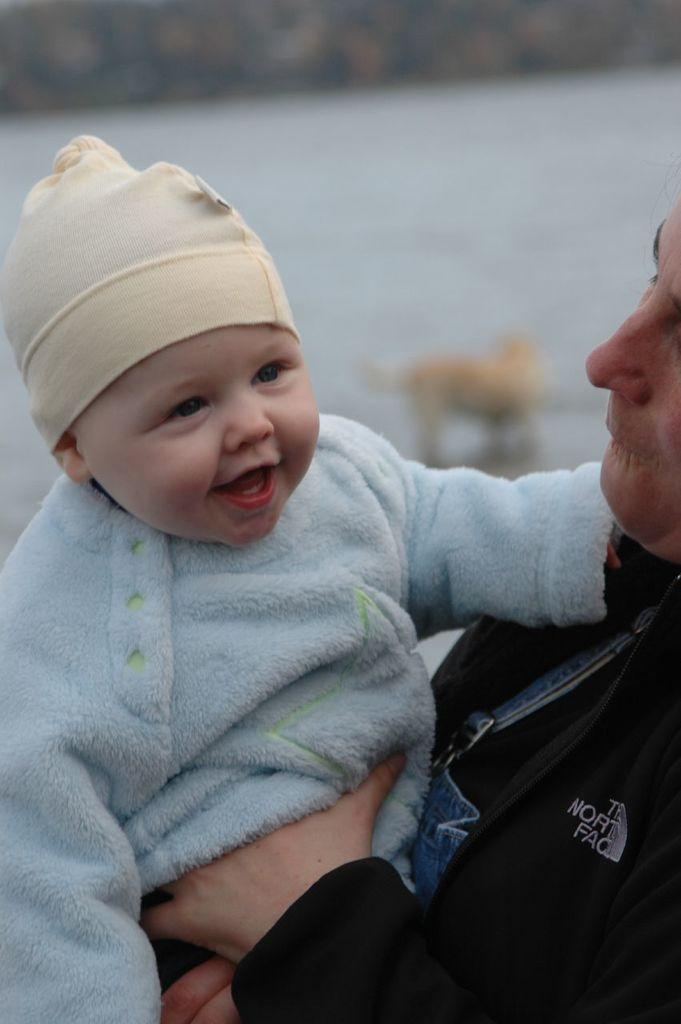What is the man doing in the image? The man is carrying a child in the image. What can be seen in the background of the image? There is a large water body visible in the image. What other living creature is present in the image? There is a dog in the image. What type of lettuce is being served in the morning in the image? There is no lettuce or morning scene present in the image; it features a man carrying a child, a large water body, and a dog. 